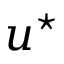Convert formula to latex. <formula><loc_0><loc_0><loc_500><loc_500>u ^ { ^ { * } }</formula> 